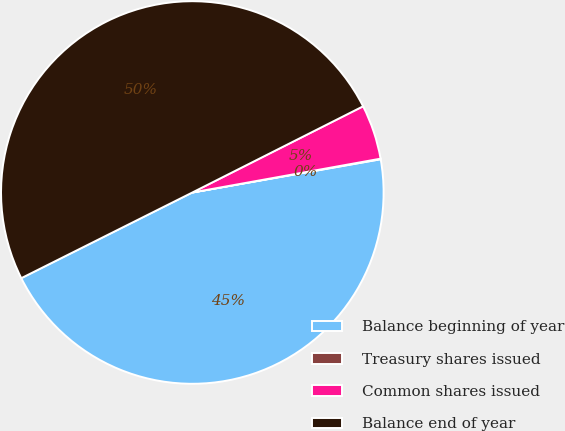<chart> <loc_0><loc_0><loc_500><loc_500><pie_chart><fcel>Balance beginning of year<fcel>Treasury shares issued<fcel>Common shares issued<fcel>Balance end of year<nl><fcel>45.39%<fcel>0.05%<fcel>4.61%<fcel>49.95%<nl></chart> 